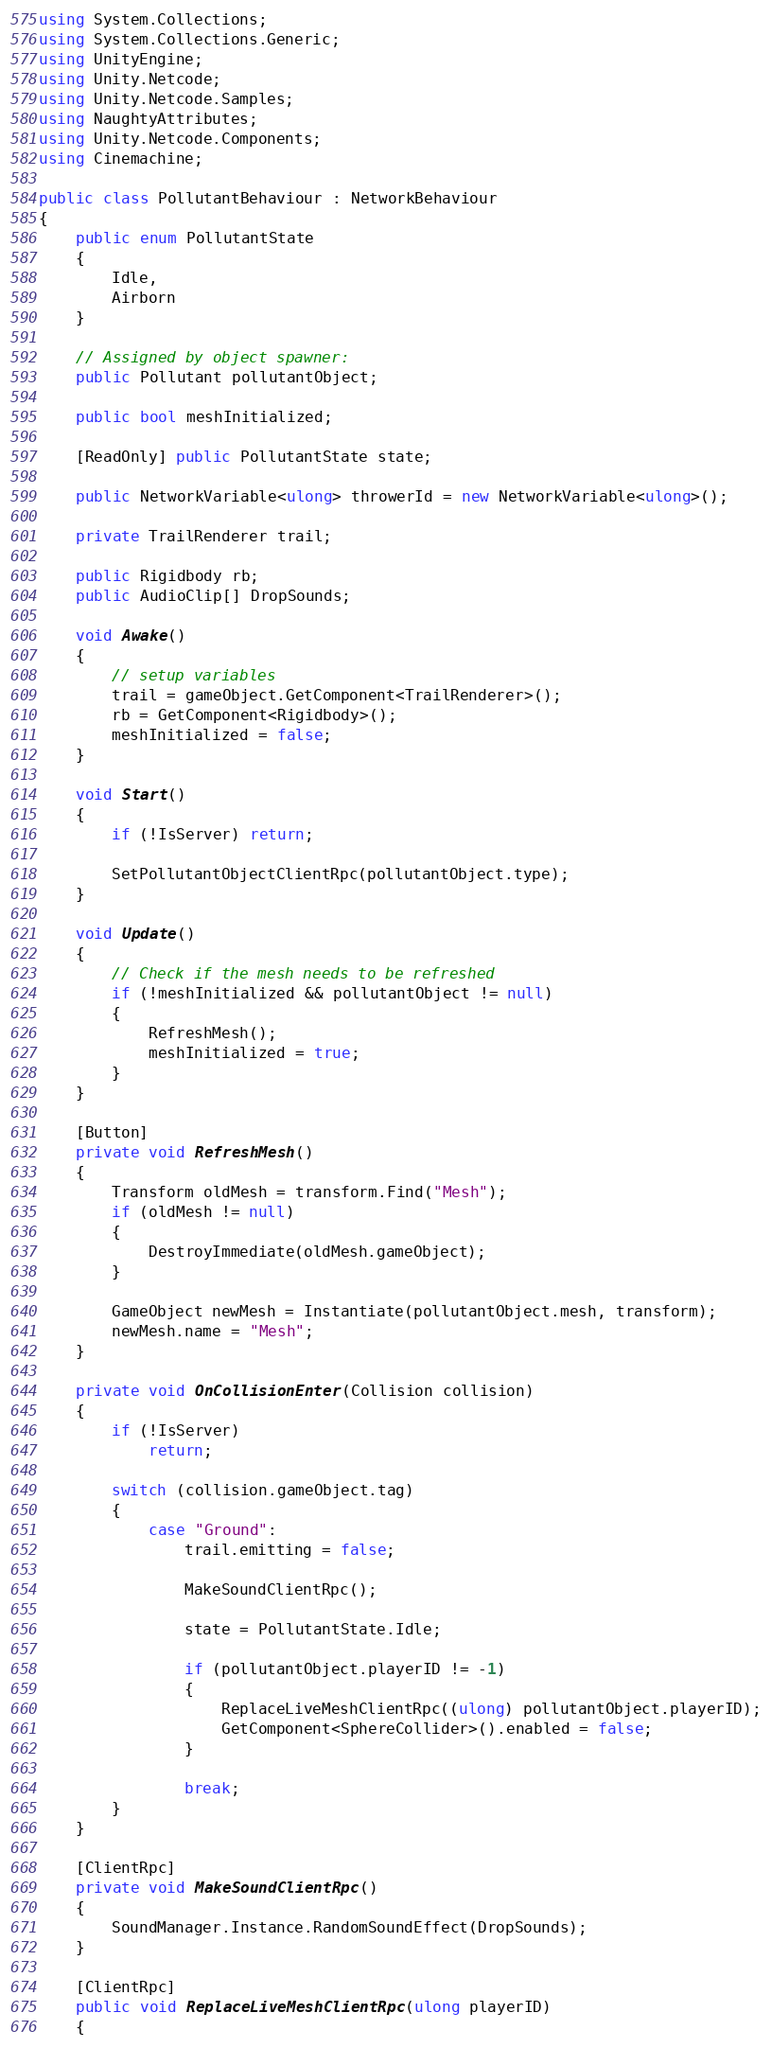Convert code to text. <code><loc_0><loc_0><loc_500><loc_500><_C#_>using System.Collections;
using System.Collections.Generic;
using UnityEngine;
using Unity.Netcode;
using Unity.Netcode.Samples;
using NaughtyAttributes;
using Unity.Netcode.Components;
using Cinemachine;

public class PollutantBehaviour : NetworkBehaviour
{
    public enum PollutantState
    {
        Idle, 
        Airborn
    }

    // Assigned by object spawner:
    public Pollutant pollutantObject;

    public bool meshInitialized;

    [ReadOnly] public PollutantState state;

    public NetworkVariable<ulong> throwerId = new NetworkVariable<ulong>();

    private TrailRenderer trail;

    public Rigidbody rb;
    public AudioClip[] DropSounds;

    void Awake()
    {
        // setup variables
        trail = gameObject.GetComponent<TrailRenderer>();
        rb = GetComponent<Rigidbody>();
        meshInitialized = false;
    }

    void Start()
    {
        if (!IsServer) return;

        SetPollutantObjectClientRpc(pollutantObject.type);
    }

    void Update()
    {
        // Check if the mesh needs to be refreshed
        if (!meshInitialized && pollutantObject != null)
        {
            RefreshMesh();
            meshInitialized = true;
        }
    }

    [Button]
    private void RefreshMesh()
    {
        Transform oldMesh = transform.Find("Mesh");
        if (oldMesh != null)
        {
            DestroyImmediate(oldMesh.gameObject);
        }

        GameObject newMesh = Instantiate(pollutantObject.mesh, transform);
        newMesh.name = "Mesh";
    }

    private void OnCollisionEnter(Collision collision)
    {
        if (!IsServer)
            return;

        switch (collision.gameObject.tag)
        {
            case "Ground":
                trail.emitting = false;

                MakeSoundClientRpc();

                state = PollutantState.Idle;

                if (pollutantObject.playerID != -1)
                {
                    ReplaceLiveMeshClientRpc((ulong) pollutantObject.playerID);
                    GetComponent<SphereCollider>().enabled = false;
                }

                break;
        }
    }

    [ClientRpc]
    private void MakeSoundClientRpc()
    {
        SoundManager.Instance.RandomSoundEffect(DropSounds);
    }
    
    [ClientRpc]
    public void ReplaceLiveMeshClientRpc(ulong playerID)
    {</code> 